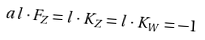<formula> <loc_0><loc_0><loc_500><loc_500>a l \cdot F _ { Z } = l \cdot K _ { Z } = l \cdot K _ { W } = - 1</formula> 